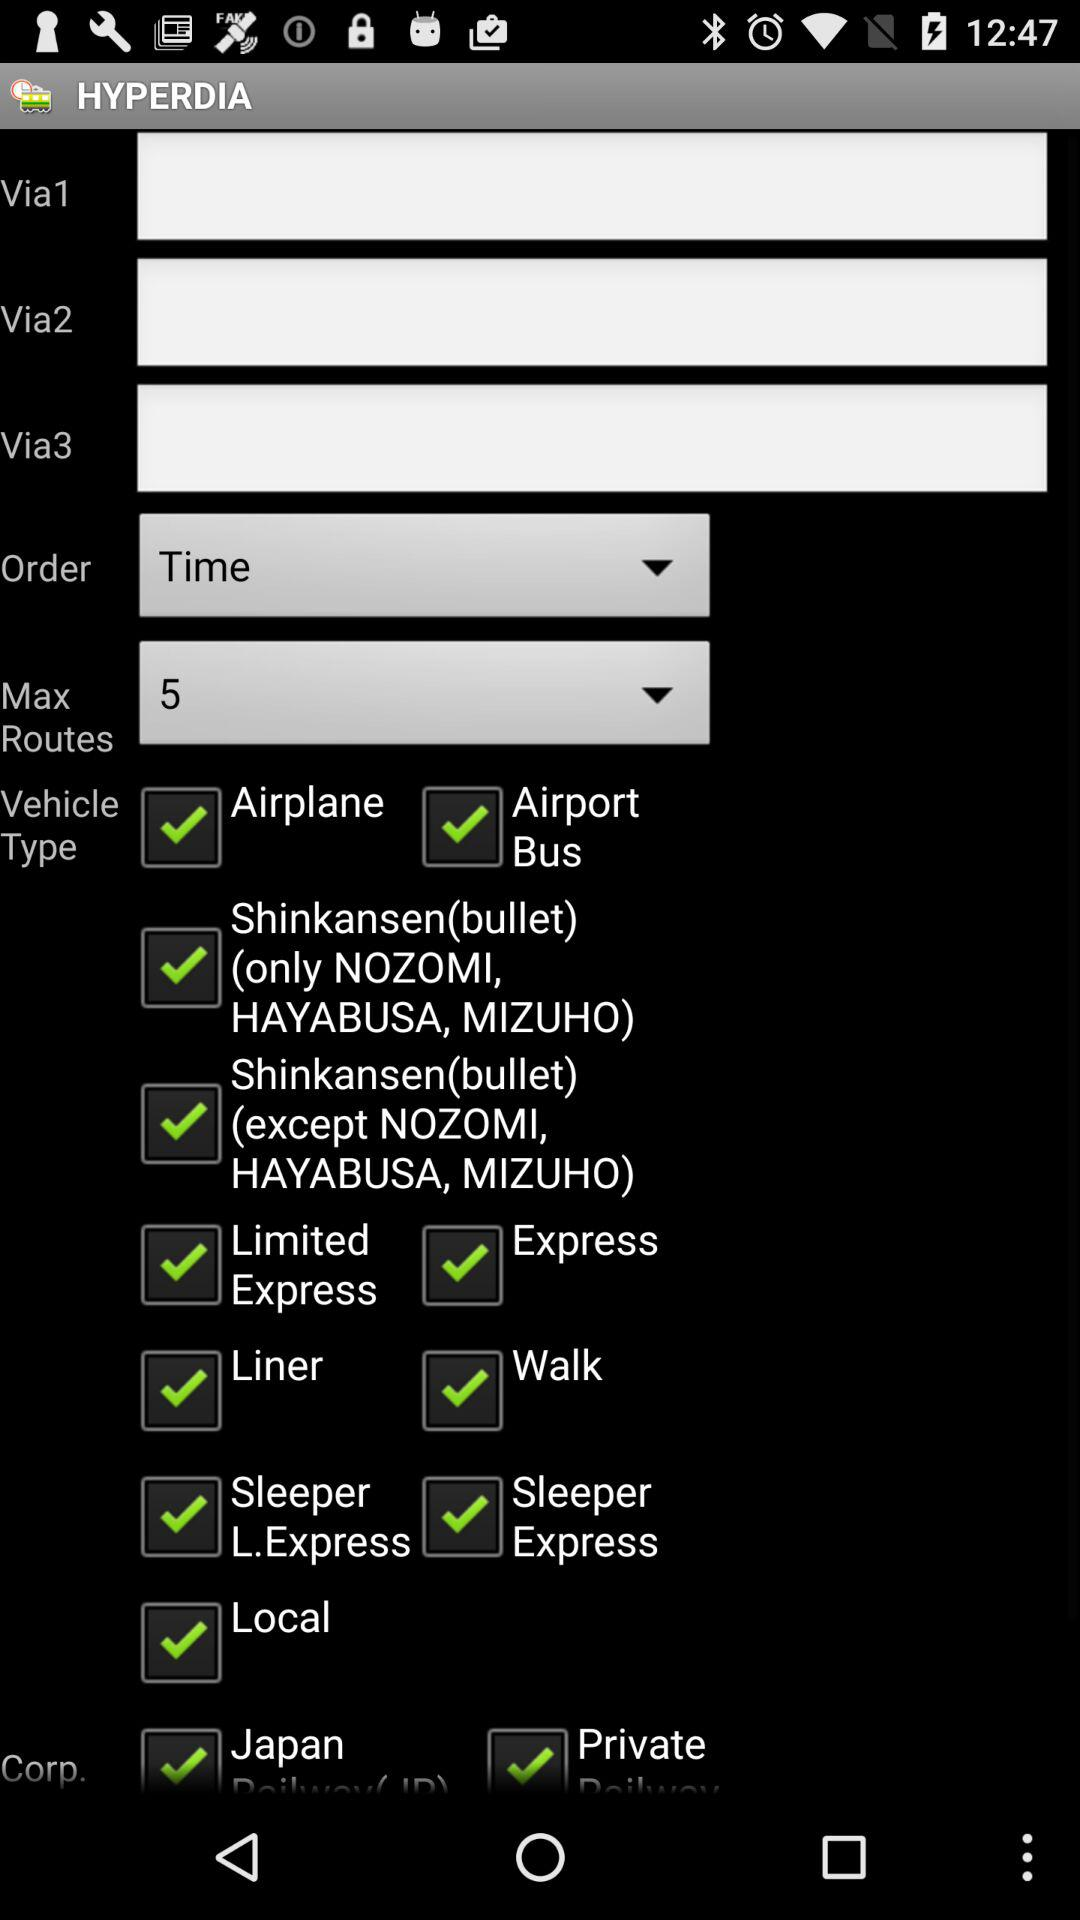What different type of vehicle has been selected? The different types of selected vehicles are "Airplane", "Airport Bus", "Shinkansen(bullet) (only NOZOMI, HAYABUSA, MIZUHO)", "Shinkansen(bullet) (except NOZOMI, HAYABUSA, MIZUHO)", "Limited Express", "Express", "Liner", "Walk", "Sleeper L.Express", "Sleeper Express" and "Local". 